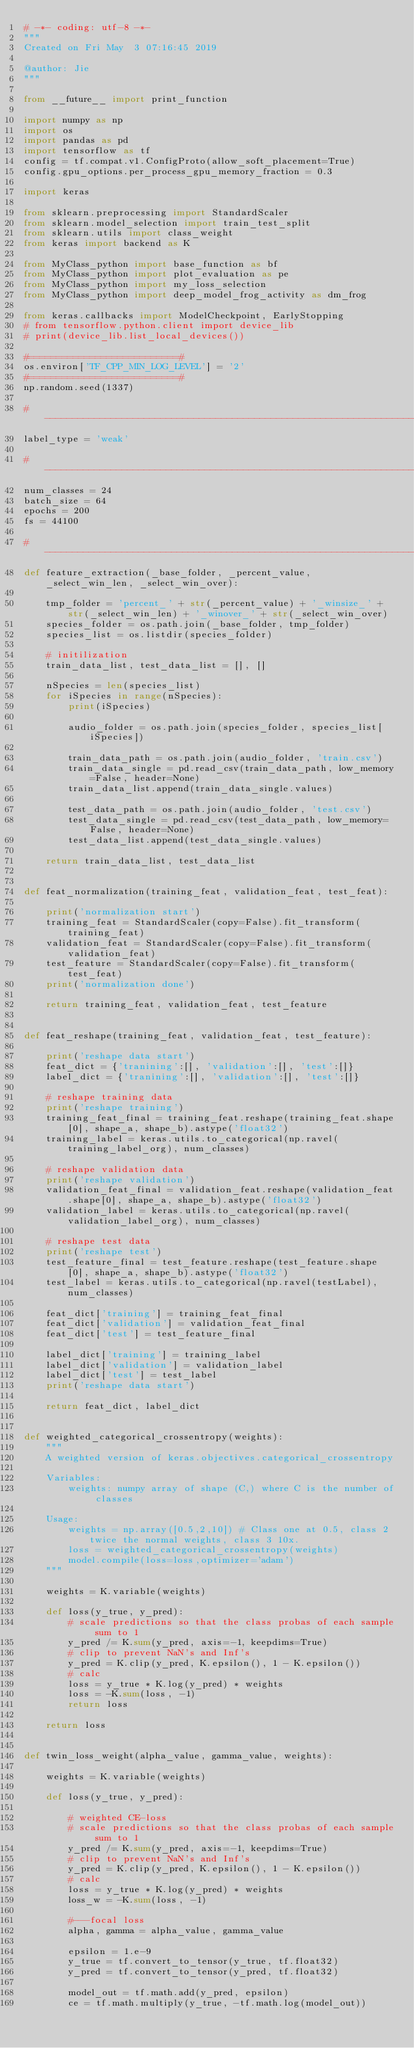<code> <loc_0><loc_0><loc_500><loc_500><_Python_># -*- coding: utf-8 -*-
"""
Created on Fri May  3 07:16:45 2019

@author: Jie
"""

from __future__ import print_function

import numpy as np
import os
import pandas as pd
import tensorflow as tf
config = tf.compat.v1.ConfigProto(allow_soft_placement=True)
config.gpu_options.per_process_gpu_memory_fraction = 0.3

import keras

from sklearn.preprocessing import StandardScaler
from sklearn.model_selection import train_test_split
from sklearn.utils import class_weight
from keras import backend as K

from MyClass_python import base_function as bf
from MyClass_python import plot_evaluation as pe
from MyClass_python import my_loss_selection
from MyClass_python import deep_model_frog_activity as dm_frog

from keras.callbacks import ModelCheckpoint, EarlyStopping
# from tensorflow.python.client import device_lib
# print(device_lib.list_local_devices())

#===========================#
os.environ['TF_CPP_MIN_LOG_LEVEL'] = '2'
#===========================#
np.random.seed(1337)
    
#-----------------------------------------------------------------------------#
label_type = 'weak'

#-----------------------------------------------------------------------------#    
num_classes = 24
batch_size = 64
epochs = 200
fs = 44100

#-----------------------------------------------------------------------------#
def feature_extraction(_base_folder, _percent_value, _select_win_len, _select_win_over):
        
    tmp_folder = 'percent_' + str(_percent_value) + '_winsize_' + str(_select_win_len) + '_winover_' + str(_select_win_over)
    species_folder = os.path.join(_base_folder, tmp_folder)    
    species_list = os.listdir(species_folder)

    # initilization
    train_data_list, test_data_list = [], []
                
    nSpecies = len(species_list)
    for iSpecies in range(nSpecies):    
        print(iSpecies)
                
        audio_folder = os.path.join(species_folder, species_list[iSpecies])
        
        train_data_path = os.path.join(audio_folder, 'train.csv')                                
        train_data_single = pd.read_csv(train_data_path, low_memory=False, header=None)                
        train_data_list.append(train_data_single.values)
        
        test_data_path = os.path.join(audio_folder, 'test.csv') 
        test_data_single = pd.read_csv(test_data_path, low_memory=False, header=None)                
        test_data_list.append(test_data_single.values)
                    
    return train_data_list, test_data_list


def feat_normalization(training_feat, validation_feat, test_feat):
    
    print('normalization start')
    training_feat = StandardScaler(copy=False).fit_transform(training_feat)
    validation_feat = StandardScaler(copy=False).fit_transform(validation_feat)
    test_feature = StandardScaler(copy=False).fit_transform(test_feat)  
    print('normalization done')    
    
    return training_feat, validation_feat, test_feature


def feat_reshape(training_feat, validation_feat, test_feature):
    
    print('reshape data start')   
    feat_dict = {'tranining':[], 'validation':[], 'test':[]}
    label_dict = {'tranining':[], 'validation':[], 'test':[]}
    
    # reshape training data
    print('reshape training')
    training_feat_final = training_feat.reshape(training_feat.shape[0], shape_a, shape_b).astype('float32')            
    training_label = keras.utils.to_categorical(np.ravel(training_label_org), num_classes)    
       
    # reshape validation data
    print('reshape validation')
    validation_feat_final = validation_feat.reshape(validation_feat.shape[0], shape_a, shape_b).astype('float32')            
    validation_label = keras.utils.to_categorical(np.ravel(validation_label_org), num_classes)    
     
    # reshape test data
    print('reshape test')
    test_feature_final = test_feature.reshape(test_feature.shape[0], shape_a, shape_b).astype('float32')            
    test_label = keras.utils.to_categorical(np.ravel(testLabel), num_classes)    
    
    feat_dict['training'] = training_feat_final
    feat_dict['validation'] = validation_feat_final
    feat_dict['test'] = test_feature_final
    
    label_dict['training'] = training_label
    label_dict['validation'] = validation_label
    label_dict['test'] = test_label
    print('reshape data start')   

    return feat_dict, label_dict


def weighted_categorical_crossentropy(weights):
    """
    A weighted version of keras.objectives.categorical_crossentropy

    Variables:
        weights: numpy array of shape (C,) where C is the number of classes

    Usage:
        weights = np.array([0.5,2,10]) # Class one at 0.5, class 2 twice the normal weights, class 3 10x.
        loss = weighted_categorical_crossentropy(weights)
        model.compile(loss=loss,optimizer='adam')
    """

    weights = K.variable(weights)

    def loss(y_true, y_pred):
        # scale predictions so that the class probas of each sample sum to 1
        y_pred /= K.sum(y_pred, axis=-1, keepdims=True)
        # clip to prevent NaN's and Inf's
        y_pred = K.clip(y_pred, K.epsilon(), 1 - K.epsilon())
        # calc
        loss = y_true * K.log(y_pred) * weights
        loss = -K.sum(loss, -1)
        return loss

    return loss


def twin_loss_weight(alpha_value, gamma_value, weights):
    
    weights = K.variable(weights)

    def loss(y_true, y_pred):
        
        # weighted CE-loss
        # scale predictions so that the class probas of each sample sum to 1
        y_pred /= K.sum(y_pred, axis=-1, keepdims=True)
        # clip to prevent NaN's and Inf's
        y_pred = K.clip(y_pred, K.epsilon(), 1 - K.epsilon())
        # calc
        loss = y_true * K.log(y_pred) * weights
        loss_w = -K.sum(loss, -1)
                
        #---focal loss
        alpha, gamma = alpha_value, gamma_value

        epsilon = 1.e-9
        y_true = tf.convert_to_tensor(y_true, tf.float32)
        y_pred = tf.convert_to_tensor(y_pred, tf.float32)
    
        model_out = tf.math.add(y_pred, epsilon)
        ce = tf.math.multiply(y_true, -tf.math.log(model_out))</code> 